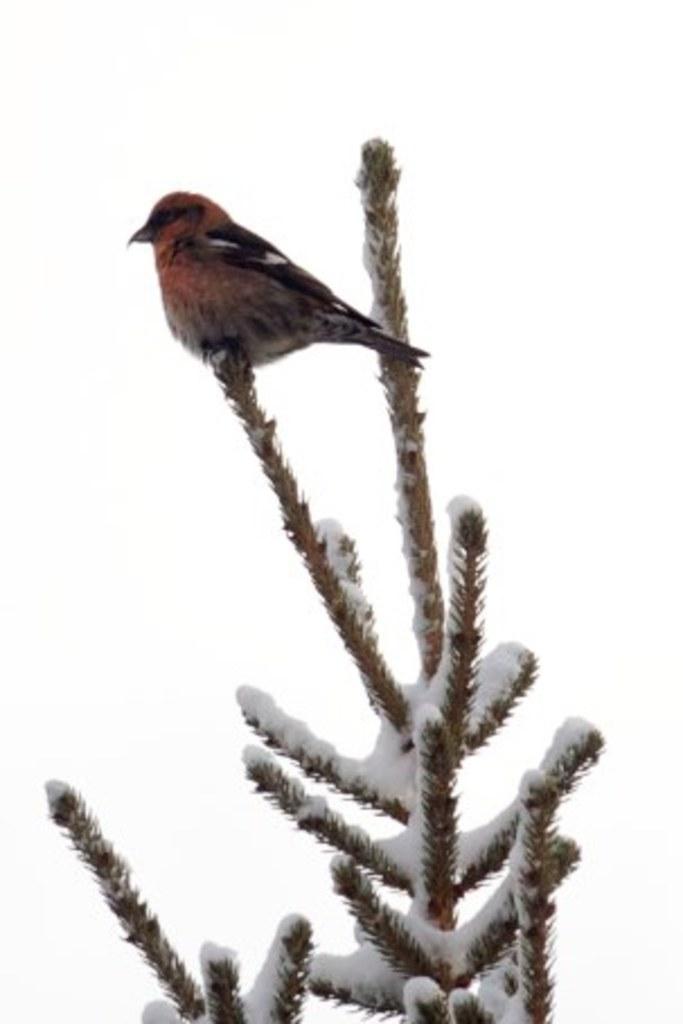Could you give a brief overview of what you see in this image? In this image we can see a plant covered with the snow, on the plant, we can see a bird and the background is white. 